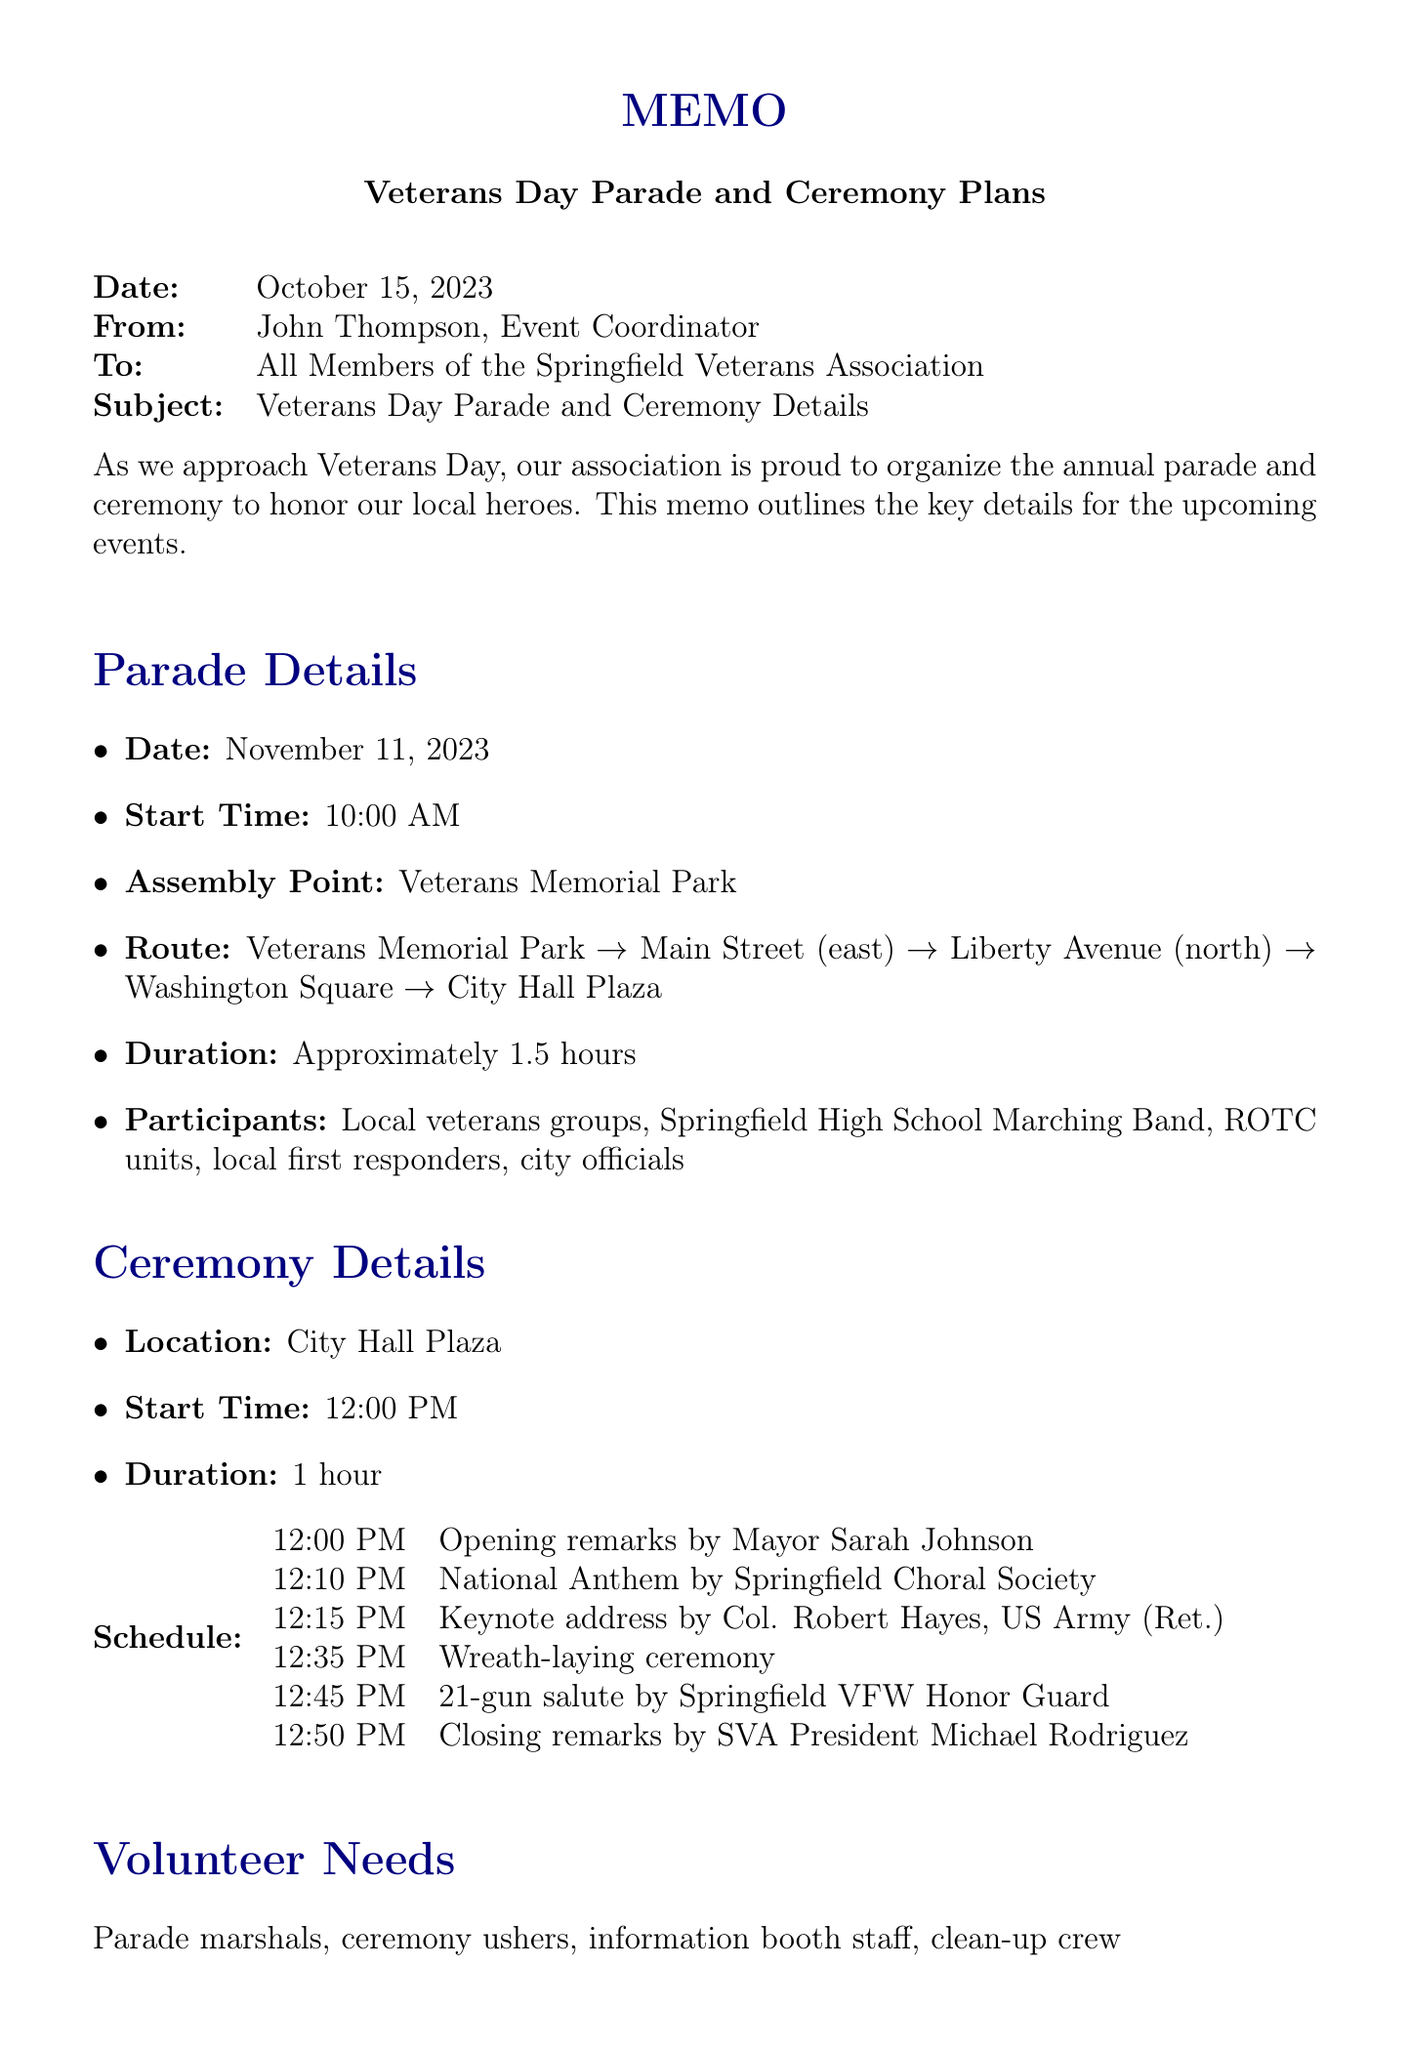what is the date of the Veterans Day parade? The date of the Veterans Day parade is explicitly mentioned in the document.
Answer: November 11, 2023 who is the keynote speaker at the ceremony? The name of the keynote speaker is listed in the schedule section of the memo.
Answer: Colonel Robert Hayes, US Army (Ret.) what is the assembly point for the parade? The assembly point for the parade is specified in the parade details section.
Answer: Veterans Memorial Park how long will the ceremony last? The duration of the ceremony is provided in the ceremony details section of the memo.
Answer: 1 hour what is the weather contingency plan documented? The weather contingency is mentioned under additional information, detailing what happens if it rains.
Answer: Ceremony moves to Springfield Community Center who will perform the National Anthem? The performer of the National Anthem is noted in the ceremony schedule.
Answer: Springfield Choral Society how many parade participants are listed? The number of different parade participants is determined by counting the items in the participants list.
Answer: Five what time does the ceremony start? The start time of the ceremony is directly stated in the ceremony details.
Answer: 12:00 PM what volunteer positions are needed? The specific volunteer needs are outlined in a section dedicated to them in the memo.
Answer: Parade marshals, ceremony ushers, information booth staff, clean-up crew 